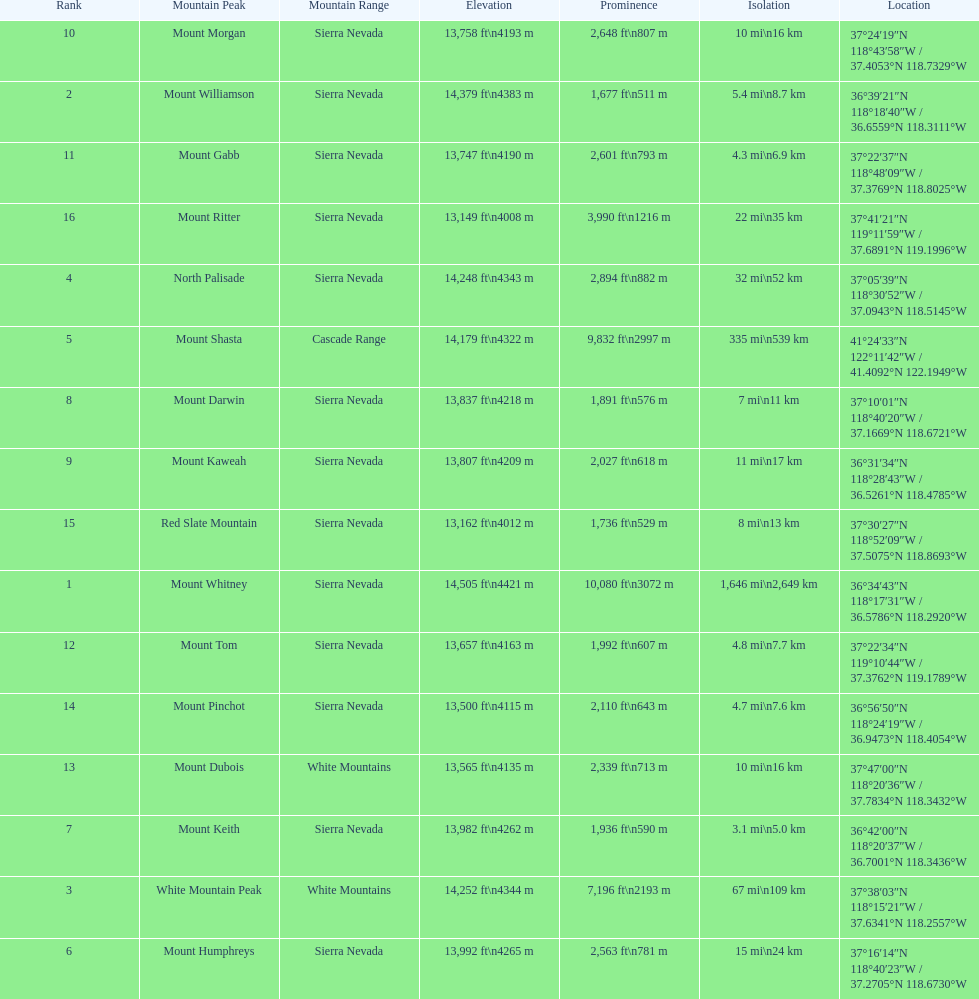Which mountain peak has the least isolation? Mount Keith. 